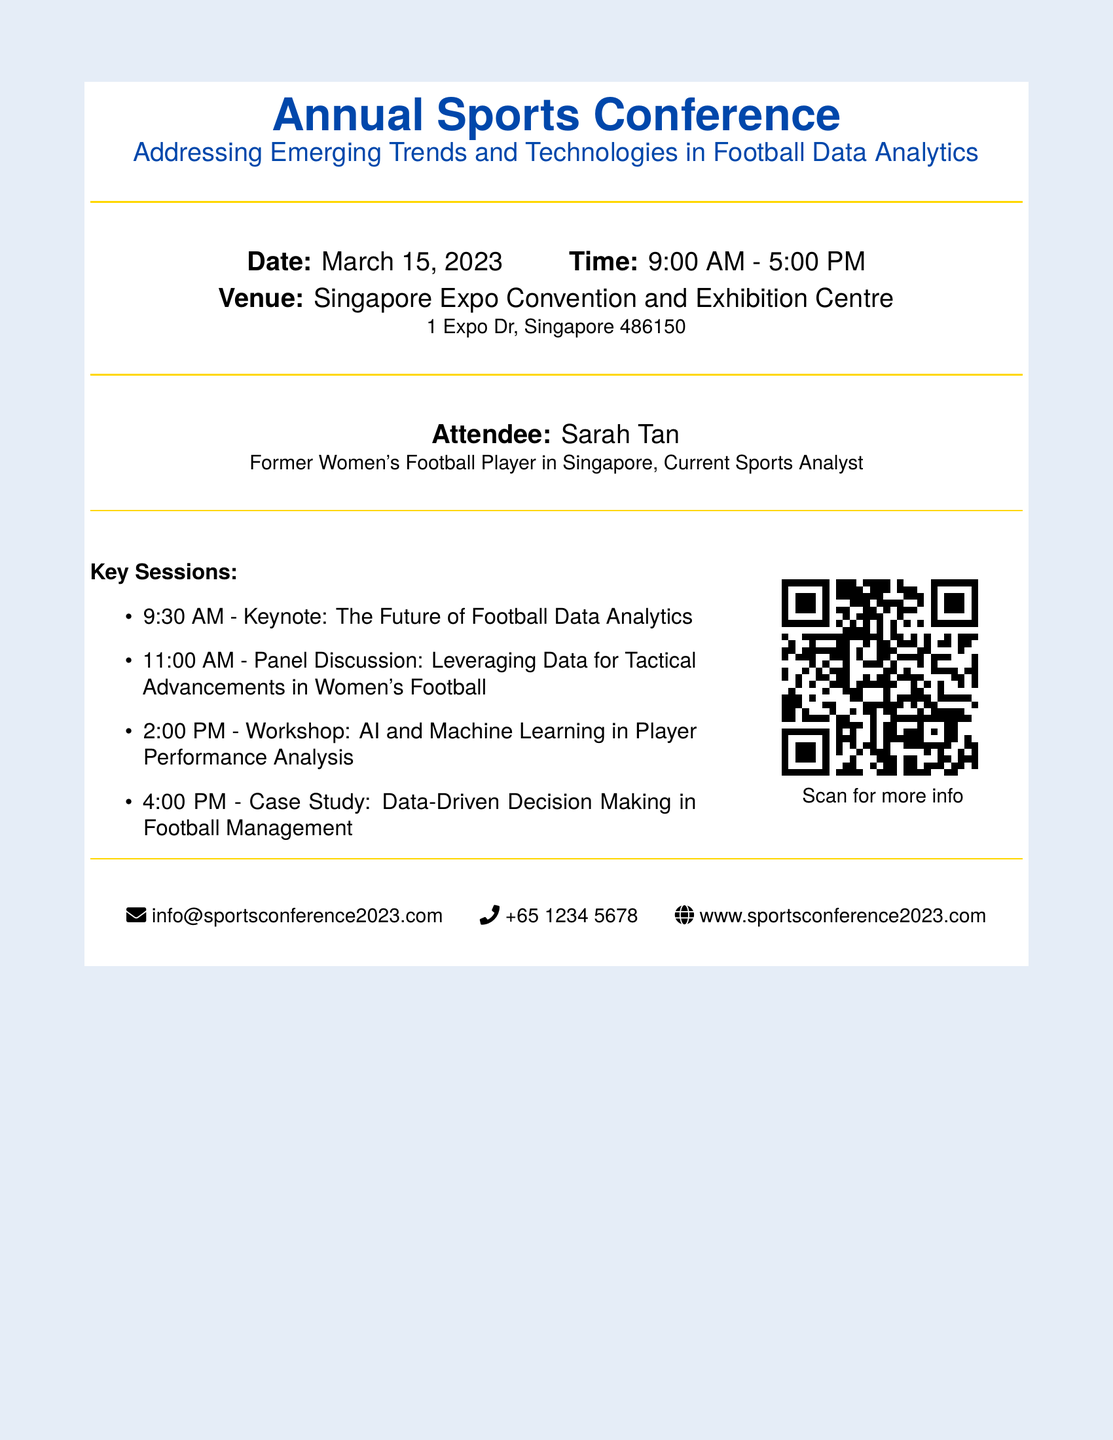What is the date of the conference? The date of the conference is specified in the document as March 15, 2023.
Answer: March 15, 2023 What time does the conference start? The document states that the conference starts at 9:00 AM.
Answer: 9:00 AM Who is the attendee mentioned in the ticket? The document lists Sarah Tan as the attendee.
Answer: Sarah Tan What is one key session topic listed? The document includes multiple key session topics; one of them is "The Future of Football Data Analytics."
Answer: The Future of Football Data Analytics Where is the venue located? The venue's address is provided in the document as 1 Expo Dr, Singapore 486150.
Answer: 1 Expo Dr, Singapore 486150 How long does the conference last? The conference runs from 9:00 AM to 5:00 PM, making it 8 hours long.
Answer: 8 hours What is the title of the workshop session? The document specifies that the workshop session title is "AI and Machine Learning in Player Performance Analysis."
Answer: AI and Machine Learning in Player Performance Analysis What is the QR code for? The QR code is used for accessing more information about the conference on the website.
Answer: More info How many key sessions are listed? The document contains a list of four key sessions.
Answer: Four 